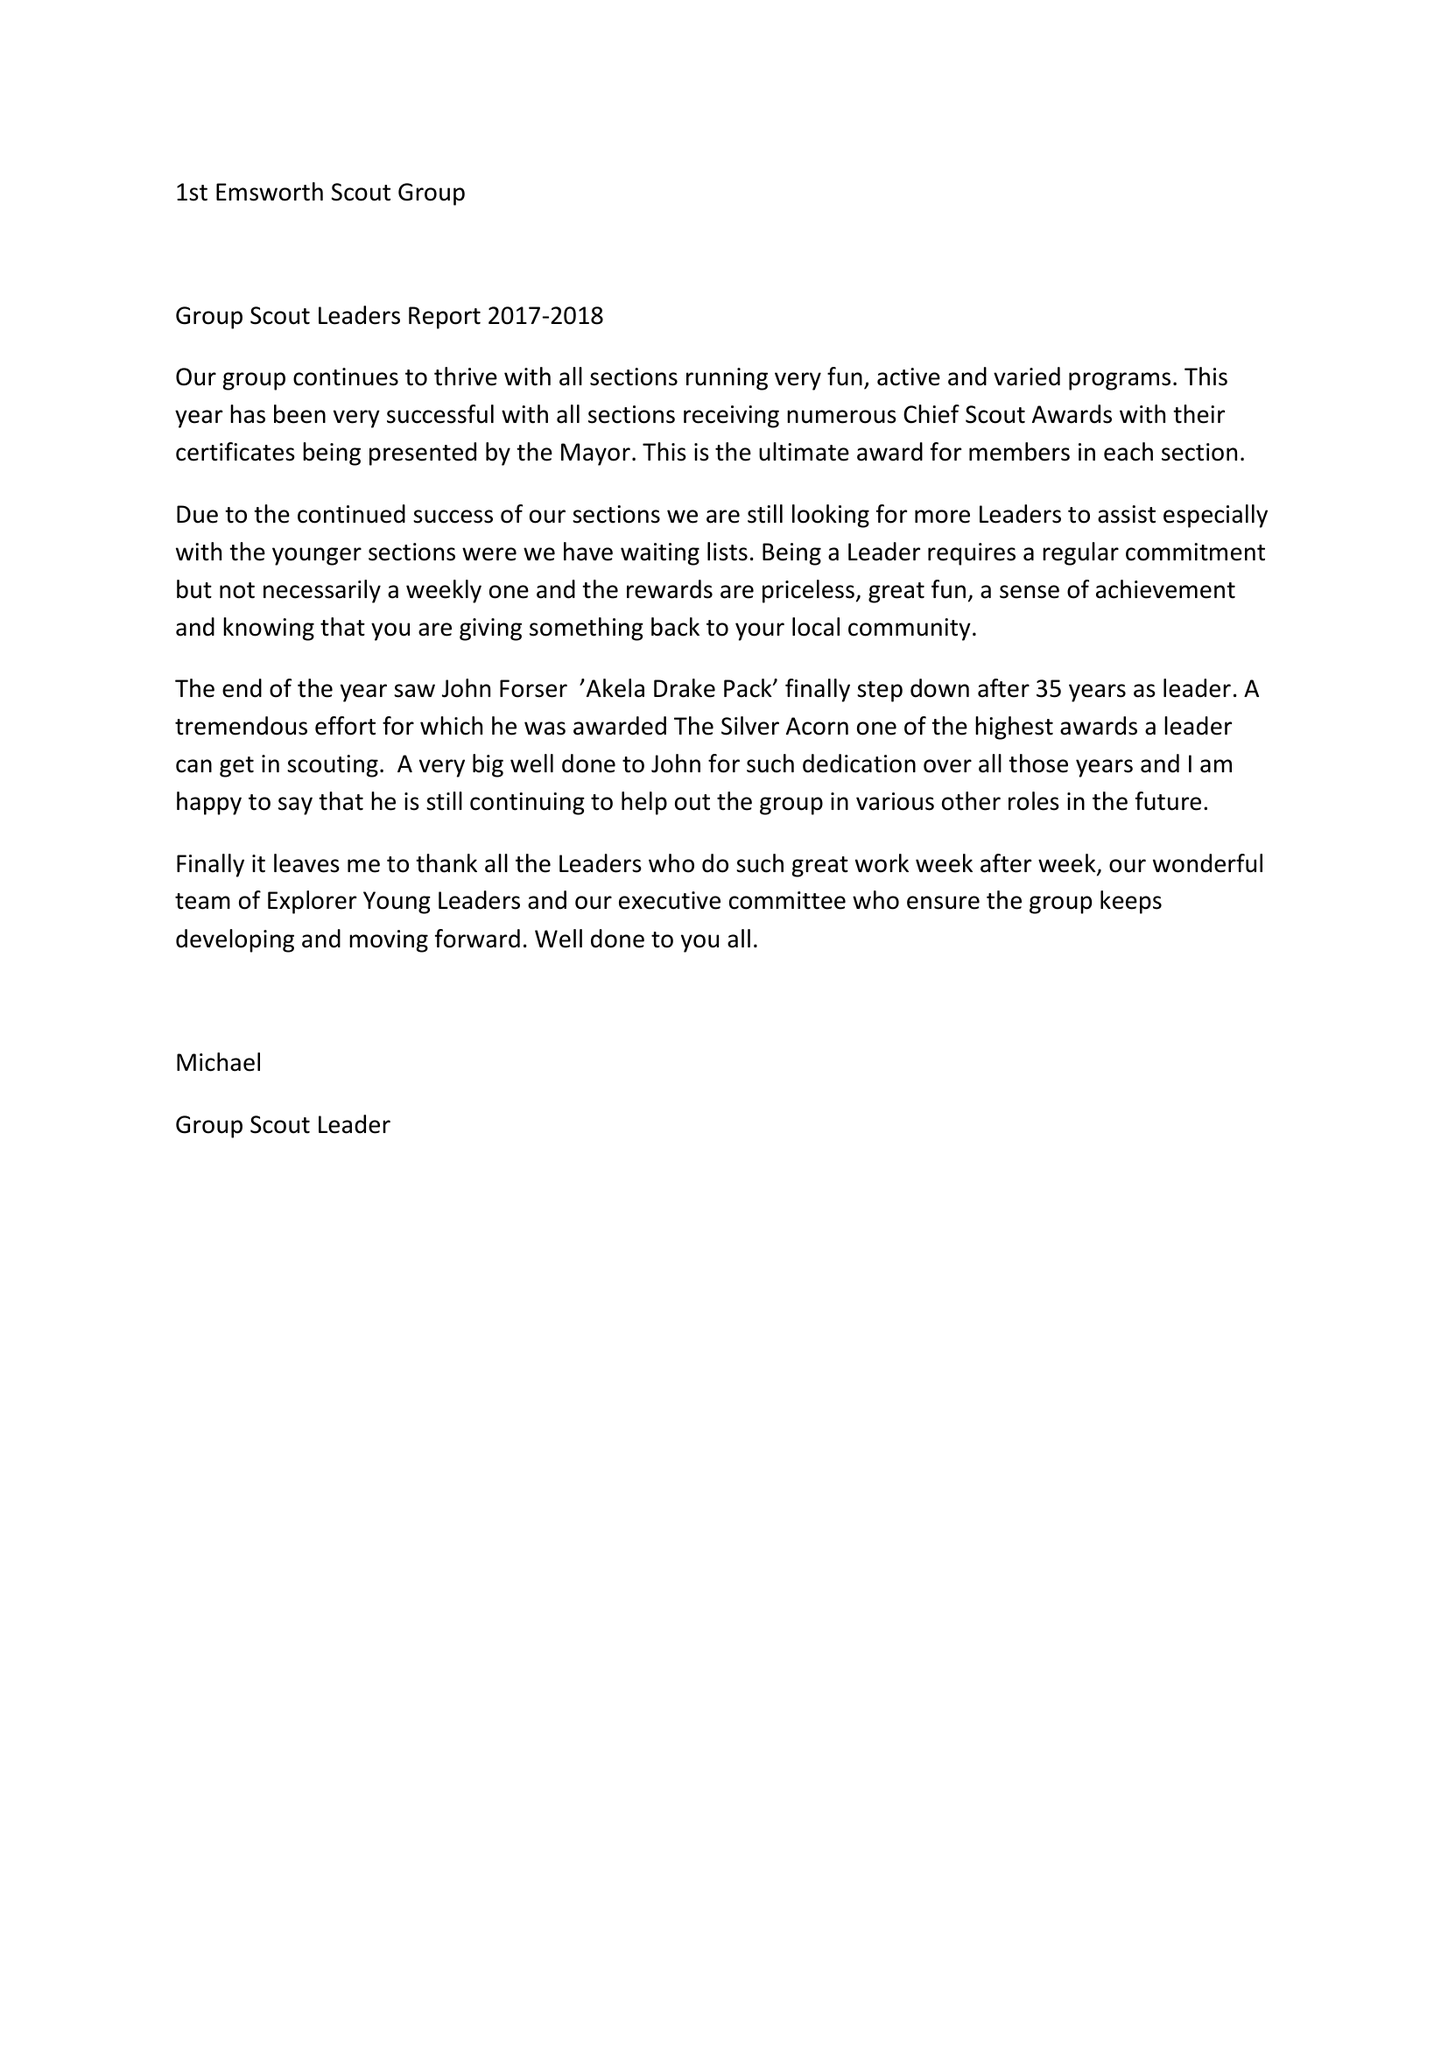What is the value for the address__postcode?
Answer the question using a single word or phrase. PO11 0SJ 